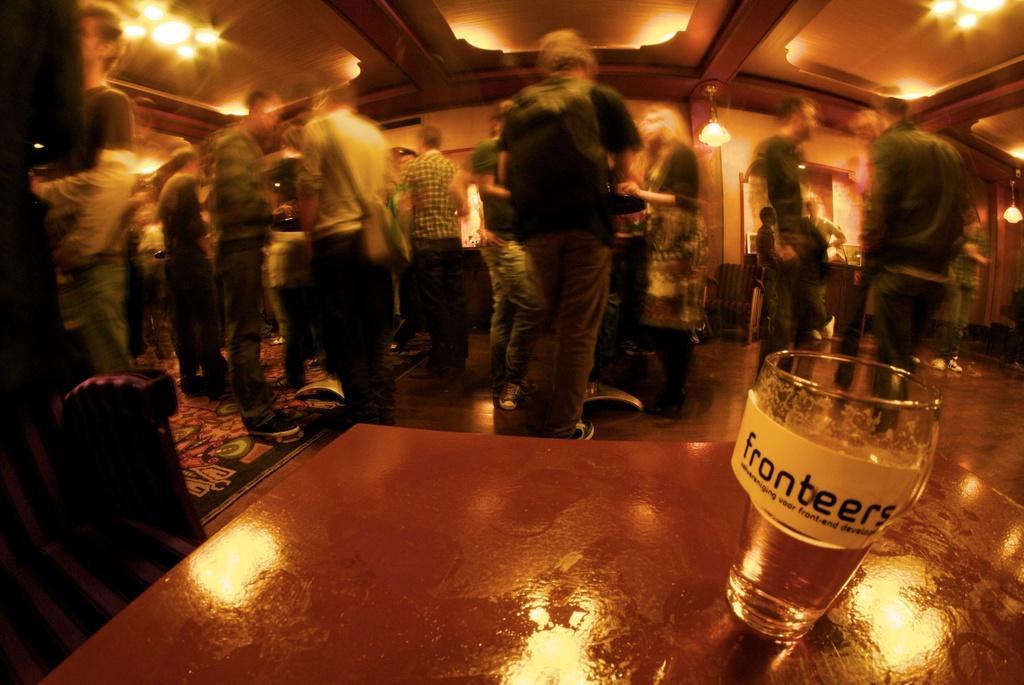Could you give a brief overview of what you see in this image? In this picture, there is a table at the bottom. On the table, there is a glass with some text. At the top, there are people. In the center, there is a man facing backwards and he is wearing a black t shirt and brown trousers. On the top, there is a ceiling with lights. 